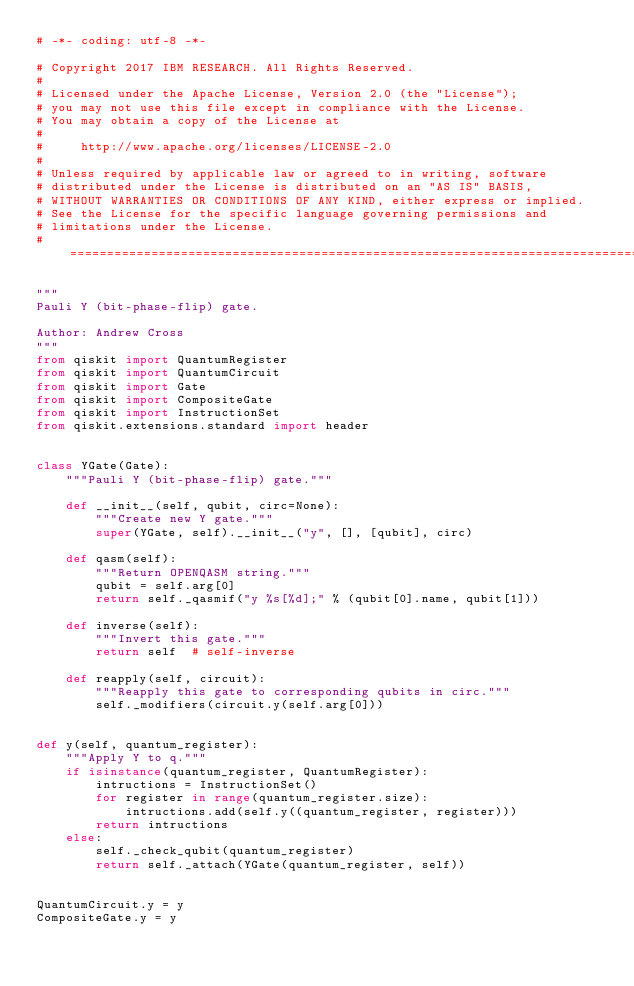<code> <loc_0><loc_0><loc_500><loc_500><_Python_># -*- coding: utf-8 -*-

# Copyright 2017 IBM RESEARCH. All Rights Reserved.
#
# Licensed under the Apache License, Version 2.0 (the "License");
# you may not use this file except in compliance with the License.
# You may obtain a copy of the License at
#
#     http://www.apache.org/licenses/LICENSE-2.0
#
# Unless required by applicable law or agreed to in writing, software
# distributed under the License is distributed on an "AS IS" BASIS,
# WITHOUT WARRANTIES OR CONDITIONS OF ANY KIND, either express or implied.
# See the License for the specific language governing permissions and
# limitations under the License.
# =============================================================================

"""
Pauli Y (bit-phase-flip) gate.

Author: Andrew Cross
"""
from qiskit import QuantumRegister
from qiskit import QuantumCircuit
from qiskit import Gate
from qiskit import CompositeGate
from qiskit import InstructionSet
from qiskit.extensions.standard import header


class YGate(Gate):
    """Pauli Y (bit-phase-flip) gate."""

    def __init__(self, qubit, circ=None):
        """Create new Y gate."""
        super(YGate, self).__init__("y", [], [qubit], circ)

    def qasm(self):
        """Return OPENQASM string."""
        qubit = self.arg[0]
        return self._qasmif("y %s[%d];" % (qubit[0].name, qubit[1]))

    def inverse(self):
        """Invert this gate."""
        return self  # self-inverse

    def reapply(self, circuit):
        """Reapply this gate to corresponding qubits in circ."""
        self._modifiers(circuit.y(self.arg[0]))


def y(self, quantum_register):
    """Apply Y to q."""
    if isinstance(quantum_register, QuantumRegister):
        intructions = InstructionSet()
        for register in range(quantum_register.size):
            intructions.add(self.y((quantum_register, register)))
        return intructions
    else:
        self._check_qubit(quantum_register)
        return self._attach(YGate(quantum_register, self))


QuantumCircuit.y = y
CompositeGate.y = y
</code> 